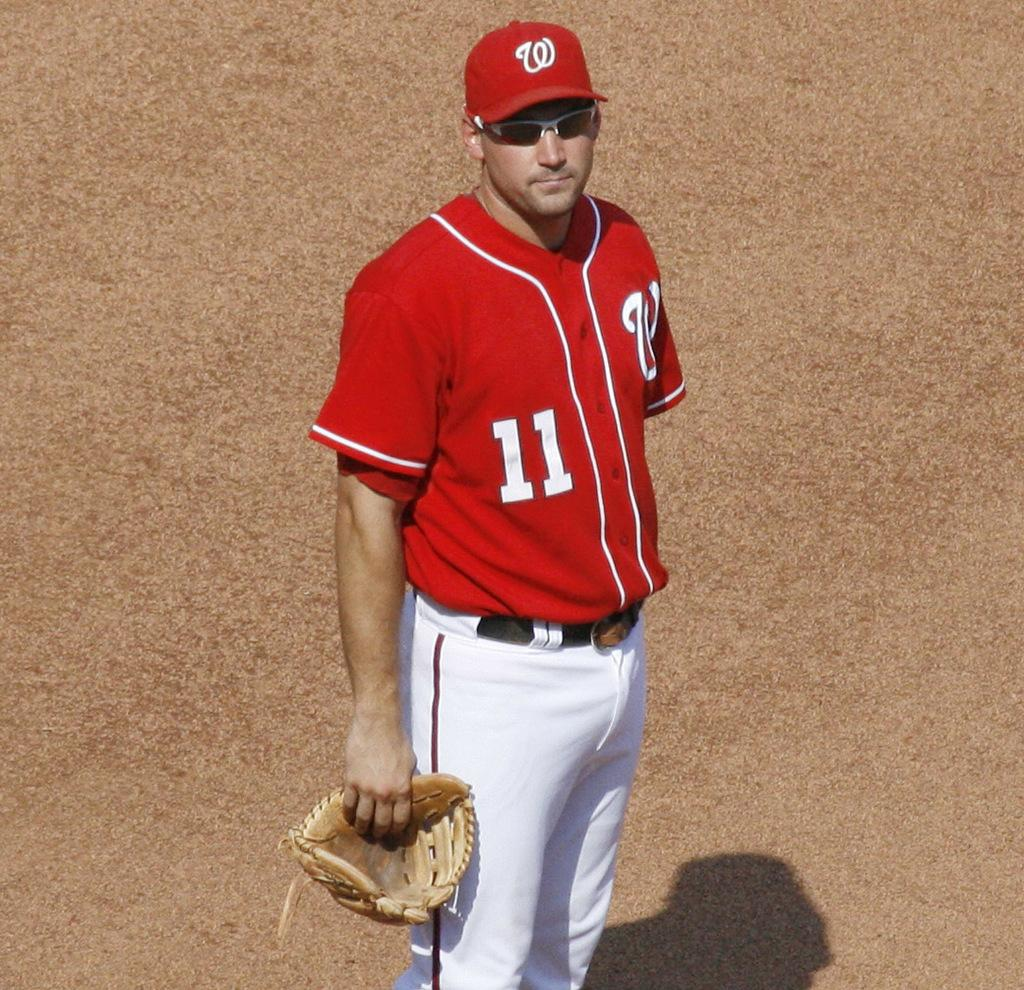<image>
Provide a brief description of the given image. A man in a baseball uniform standing on a field holding a baseball glove and a W on his jersey. 